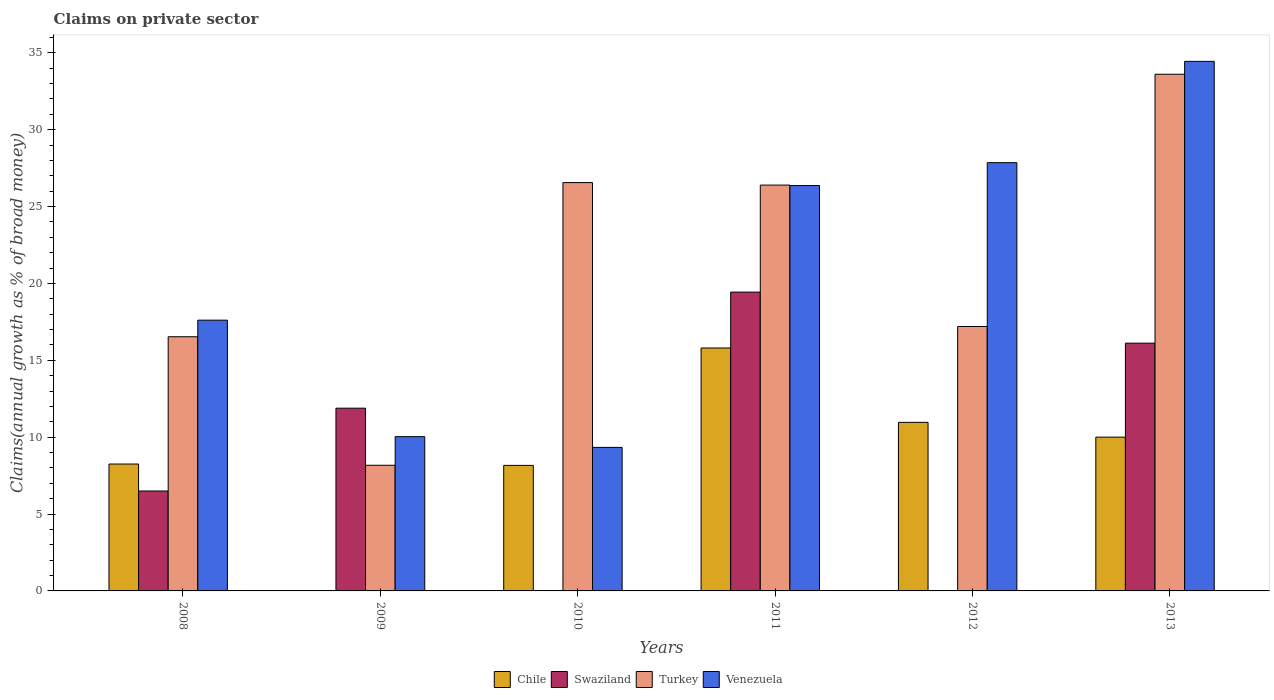How many groups of bars are there?
Provide a short and direct response. 6. Are the number of bars per tick equal to the number of legend labels?
Your response must be concise. No. Are the number of bars on each tick of the X-axis equal?
Provide a short and direct response. No. How many bars are there on the 1st tick from the left?
Your answer should be compact. 4. How many bars are there on the 6th tick from the right?
Give a very brief answer. 4. What is the label of the 1st group of bars from the left?
Provide a succinct answer. 2008. What is the percentage of broad money claimed on private sector in Venezuela in 2009?
Ensure brevity in your answer.  10.03. Across all years, what is the maximum percentage of broad money claimed on private sector in Venezuela?
Ensure brevity in your answer.  34.44. Across all years, what is the minimum percentage of broad money claimed on private sector in Turkey?
Your answer should be very brief. 8.17. In which year was the percentage of broad money claimed on private sector in Venezuela maximum?
Offer a very short reply. 2013. What is the total percentage of broad money claimed on private sector in Turkey in the graph?
Ensure brevity in your answer.  128.45. What is the difference between the percentage of broad money claimed on private sector in Swaziland in 2008 and that in 2011?
Your response must be concise. -12.94. What is the difference between the percentage of broad money claimed on private sector in Chile in 2011 and the percentage of broad money claimed on private sector in Turkey in 2010?
Ensure brevity in your answer.  -10.76. What is the average percentage of broad money claimed on private sector in Turkey per year?
Give a very brief answer. 21.41. In the year 2010, what is the difference between the percentage of broad money claimed on private sector in Venezuela and percentage of broad money claimed on private sector in Chile?
Provide a short and direct response. 1.17. What is the ratio of the percentage of broad money claimed on private sector in Swaziland in 2009 to that in 2013?
Your answer should be compact. 0.74. Is the difference between the percentage of broad money claimed on private sector in Venezuela in 2010 and 2012 greater than the difference between the percentage of broad money claimed on private sector in Chile in 2010 and 2012?
Your answer should be compact. No. What is the difference between the highest and the second highest percentage of broad money claimed on private sector in Chile?
Ensure brevity in your answer.  4.84. What is the difference between the highest and the lowest percentage of broad money claimed on private sector in Chile?
Your answer should be very brief. 15.8. Is the sum of the percentage of broad money claimed on private sector in Venezuela in 2009 and 2011 greater than the maximum percentage of broad money claimed on private sector in Turkey across all years?
Make the answer very short. Yes. Is it the case that in every year, the sum of the percentage of broad money claimed on private sector in Chile and percentage of broad money claimed on private sector in Turkey is greater than the sum of percentage of broad money claimed on private sector in Venezuela and percentage of broad money claimed on private sector in Swaziland?
Your answer should be very brief. No. Is it the case that in every year, the sum of the percentage of broad money claimed on private sector in Venezuela and percentage of broad money claimed on private sector in Chile is greater than the percentage of broad money claimed on private sector in Turkey?
Your answer should be very brief. No. How many years are there in the graph?
Give a very brief answer. 6. What is the difference between two consecutive major ticks on the Y-axis?
Offer a very short reply. 5. Are the values on the major ticks of Y-axis written in scientific E-notation?
Your answer should be compact. No. How many legend labels are there?
Give a very brief answer. 4. How are the legend labels stacked?
Give a very brief answer. Horizontal. What is the title of the graph?
Offer a very short reply. Claims on private sector. What is the label or title of the Y-axis?
Provide a short and direct response. Claims(annual growth as % of broad money). What is the Claims(annual growth as % of broad money) of Chile in 2008?
Give a very brief answer. 8.25. What is the Claims(annual growth as % of broad money) in Swaziland in 2008?
Your response must be concise. 6.5. What is the Claims(annual growth as % of broad money) of Turkey in 2008?
Keep it short and to the point. 16.53. What is the Claims(annual growth as % of broad money) of Venezuela in 2008?
Provide a succinct answer. 17.61. What is the Claims(annual growth as % of broad money) in Swaziland in 2009?
Offer a terse response. 11.89. What is the Claims(annual growth as % of broad money) of Turkey in 2009?
Offer a very short reply. 8.17. What is the Claims(annual growth as % of broad money) in Venezuela in 2009?
Ensure brevity in your answer.  10.03. What is the Claims(annual growth as % of broad money) in Chile in 2010?
Provide a succinct answer. 8.16. What is the Claims(annual growth as % of broad money) of Turkey in 2010?
Keep it short and to the point. 26.56. What is the Claims(annual growth as % of broad money) of Venezuela in 2010?
Provide a short and direct response. 9.33. What is the Claims(annual growth as % of broad money) in Chile in 2011?
Keep it short and to the point. 15.8. What is the Claims(annual growth as % of broad money) in Swaziland in 2011?
Your answer should be very brief. 19.43. What is the Claims(annual growth as % of broad money) of Turkey in 2011?
Give a very brief answer. 26.39. What is the Claims(annual growth as % of broad money) in Venezuela in 2011?
Offer a very short reply. 26.37. What is the Claims(annual growth as % of broad money) of Chile in 2012?
Offer a terse response. 10.96. What is the Claims(annual growth as % of broad money) of Turkey in 2012?
Ensure brevity in your answer.  17.2. What is the Claims(annual growth as % of broad money) of Venezuela in 2012?
Ensure brevity in your answer.  27.85. What is the Claims(annual growth as % of broad money) in Chile in 2013?
Your response must be concise. 10. What is the Claims(annual growth as % of broad money) in Swaziland in 2013?
Provide a succinct answer. 16.11. What is the Claims(annual growth as % of broad money) in Turkey in 2013?
Make the answer very short. 33.6. What is the Claims(annual growth as % of broad money) in Venezuela in 2013?
Your answer should be very brief. 34.44. Across all years, what is the maximum Claims(annual growth as % of broad money) in Chile?
Provide a short and direct response. 15.8. Across all years, what is the maximum Claims(annual growth as % of broad money) of Swaziland?
Your answer should be very brief. 19.43. Across all years, what is the maximum Claims(annual growth as % of broad money) of Turkey?
Your answer should be very brief. 33.6. Across all years, what is the maximum Claims(annual growth as % of broad money) of Venezuela?
Your answer should be compact. 34.44. Across all years, what is the minimum Claims(annual growth as % of broad money) in Chile?
Your answer should be very brief. 0. Across all years, what is the minimum Claims(annual growth as % of broad money) in Swaziland?
Your answer should be compact. 0. Across all years, what is the minimum Claims(annual growth as % of broad money) in Turkey?
Offer a very short reply. 8.17. Across all years, what is the minimum Claims(annual growth as % of broad money) of Venezuela?
Keep it short and to the point. 9.33. What is the total Claims(annual growth as % of broad money) of Chile in the graph?
Provide a succinct answer. 53.18. What is the total Claims(annual growth as % of broad money) of Swaziland in the graph?
Keep it short and to the point. 53.93. What is the total Claims(annual growth as % of broad money) of Turkey in the graph?
Keep it short and to the point. 128.45. What is the total Claims(annual growth as % of broad money) of Venezuela in the graph?
Make the answer very short. 125.64. What is the difference between the Claims(annual growth as % of broad money) of Swaziland in 2008 and that in 2009?
Make the answer very short. -5.39. What is the difference between the Claims(annual growth as % of broad money) in Turkey in 2008 and that in 2009?
Provide a short and direct response. 8.36. What is the difference between the Claims(annual growth as % of broad money) of Venezuela in 2008 and that in 2009?
Offer a very short reply. 7.58. What is the difference between the Claims(annual growth as % of broad money) of Chile in 2008 and that in 2010?
Offer a very short reply. 0.09. What is the difference between the Claims(annual growth as % of broad money) in Turkey in 2008 and that in 2010?
Your answer should be very brief. -10.03. What is the difference between the Claims(annual growth as % of broad money) in Venezuela in 2008 and that in 2010?
Give a very brief answer. 8.27. What is the difference between the Claims(annual growth as % of broad money) of Chile in 2008 and that in 2011?
Provide a short and direct response. -7.55. What is the difference between the Claims(annual growth as % of broad money) of Swaziland in 2008 and that in 2011?
Make the answer very short. -12.94. What is the difference between the Claims(annual growth as % of broad money) in Turkey in 2008 and that in 2011?
Offer a very short reply. -9.86. What is the difference between the Claims(annual growth as % of broad money) in Venezuela in 2008 and that in 2011?
Ensure brevity in your answer.  -8.76. What is the difference between the Claims(annual growth as % of broad money) in Chile in 2008 and that in 2012?
Your answer should be compact. -2.71. What is the difference between the Claims(annual growth as % of broad money) of Turkey in 2008 and that in 2012?
Give a very brief answer. -0.67. What is the difference between the Claims(annual growth as % of broad money) in Venezuela in 2008 and that in 2012?
Provide a short and direct response. -10.24. What is the difference between the Claims(annual growth as % of broad money) in Chile in 2008 and that in 2013?
Make the answer very short. -1.75. What is the difference between the Claims(annual growth as % of broad money) in Swaziland in 2008 and that in 2013?
Make the answer very short. -9.62. What is the difference between the Claims(annual growth as % of broad money) of Turkey in 2008 and that in 2013?
Offer a terse response. -17.07. What is the difference between the Claims(annual growth as % of broad money) of Venezuela in 2008 and that in 2013?
Ensure brevity in your answer.  -16.83. What is the difference between the Claims(annual growth as % of broad money) of Turkey in 2009 and that in 2010?
Your response must be concise. -18.39. What is the difference between the Claims(annual growth as % of broad money) of Venezuela in 2009 and that in 2010?
Give a very brief answer. 0.7. What is the difference between the Claims(annual growth as % of broad money) of Swaziland in 2009 and that in 2011?
Offer a terse response. -7.55. What is the difference between the Claims(annual growth as % of broad money) of Turkey in 2009 and that in 2011?
Provide a short and direct response. -18.22. What is the difference between the Claims(annual growth as % of broad money) of Venezuela in 2009 and that in 2011?
Make the answer very short. -16.33. What is the difference between the Claims(annual growth as % of broad money) of Turkey in 2009 and that in 2012?
Your response must be concise. -9.03. What is the difference between the Claims(annual growth as % of broad money) of Venezuela in 2009 and that in 2012?
Give a very brief answer. -17.82. What is the difference between the Claims(annual growth as % of broad money) of Swaziland in 2009 and that in 2013?
Your answer should be very brief. -4.23. What is the difference between the Claims(annual growth as % of broad money) of Turkey in 2009 and that in 2013?
Provide a short and direct response. -25.43. What is the difference between the Claims(annual growth as % of broad money) of Venezuela in 2009 and that in 2013?
Keep it short and to the point. -24.41. What is the difference between the Claims(annual growth as % of broad money) of Chile in 2010 and that in 2011?
Provide a short and direct response. -7.63. What is the difference between the Claims(annual growth as % of broad money) in Turkey in 2010 and that in 2011?
Offer a terse response. 0.16. What is the difference between the Claims(annual growth as % of broad money) of Venezuela in 2010 and that in 2011?
Your answer should be very brief. -17.03. What is the difference between the Claims(annual growth as % of broad money) of Chile in 2010 and that in 2012?
Provide a short and direct response. -2.8. What is the difference between the Claims(annual growth as % of broad money) of Turkey in 2010 and that in 2012?
Your answer should be compact. 9.36. What is the difference between the Claims(annual growth as % of broad money) in Venezuela in 2010 and that in 2012?
Your response must be concise. -18.52. What is the difference between the Claims(annual growth as % of broad money) of Chile in 2010 and that in 2013?
Offer a terse response. -1.84. What is the difference between the Claims(annual growth as % of broad money) of Turkey in 2010 and that in 2013?
Make the answer very short. -7.05. What is the difference between the Claims(annual growth as % of broad money) in Venezuela in 2010 and that in 2013?
Offer a very short reply. -25.11. What is the difference between the Claims(annual growth as % of broad money) in Chile in 2011 and that in 2012?
Make the answer very short. 4.84. What is the difference between the Claims(annual growth as % of broad money) in Turkey in 2011 and that in 2012?
Offer a terse response. 9.2. What is the difference between the Claims(annual growth as % of broad money) of Venezuela in 2011 and that in 2012?
Offer a terse response. -1.49. What is the difference between the Claims(annual growth as % of broad money) in Chile in 2011 and that in 2013?
Your response must be concise. 5.8. What is the difference between the Claims(annual growth as % of broad money) of Swaziland in 2011 and that in 2013?
Provide a short and direct response. 3.32. What is the difference between the Claims(annual growth as % of broad money) of Turkey in 2011 and that in 2013?
Make the answer very short. -7.21. What is the difference between the Claims(annual growth as % of broad money) in Venezuela in 2011 and that in 2013?
Your response must be concise. -8.08. What is the difference between the Claims(annual growth as % of broad money) in Chile in 2012 and that in 2013?
Provide a short and direct response. 0.96. What is the difference between the Claims(annual growth as % of broad money) of Turkey in 2012 and that in 2013?
Offer a very short reply. -16.41. What is the difference between the Claims(annual growth as % of broad money) of Venezuela in 2012 and that in 2013?
Your response must be concise. -6.59. What is the difference between the Claims(annual growth as % of broad money) of Chile in 2008 and the Claims(annual growth as % of broad money) of Swaziland in 2009?
Make the answer very short. -3.63. What is the difference between the Claims(annual growth as % of broad money) of Chile in 2008 and the Claims(annual growth as % of broad money) of Turkey in 2009?
Offer a very short reply. 0.08. What is the difference between the Claims(annual growth as % of broad money) of Chile in 2008 and the Claims(annual growth as % of broad money) of Venezuela in 2009?
Your answer should be very brief. -1.78. What is the difference between the Claims(annual growth as % of broad money) of Swaziland in 2008 and the Claims(annual growth as % of broad money) of Turkey in 2009?
Your answer should be very brief. -1.67. What is the difference between the Claims(annual growth as % of broad money) of Swaziland in 2008 and the Claims(annual growth as % of broad money) of Venezuela in 2009?
Your response must be concise. -3.54. What is the difference between the Claims(annual growth as % of broad money) of Turkey in 2008 and the Claims(annual growth as % of broad money) of Venezuela in 2009?
Your answer should be very brief. 6.5. What is the difference between the Claims(annual growth as % of broad money) of Chile in 2008 and the Claims(annual growth as % of broad money) of Turkey in 2010?
Ensure brevity in your answer.  -18.3. What is the difference between the Claims(annual growth as % of broad money) in Chile in 2008 and the Claims(annual growth as % of broad money) in Venezuela in 2010?
Make the answer very short. -1.08. What is the difference between the Claims(annual growth as % of broad money) of Swaziland in 2008 and the Claims(annual growth as % of broad money) of Turkey in 2010?
Make the answer very short. -20.06. What is the difference between the Claims(annual growth as % of broad money) in Swaziland in 2008 and the Claims(annual growth as % of broad money) in Venezuela in 2010?
Give a very brief answer. -2.84. What is the difference between the Claims(annual growth as % of broad money) of Turkey in 2008 and the Claims(annual growth as % of broad money) of Venezuela in 2010?
Your response must be concise. 7.2. What is the difference between the Claims(annual growth as % of broad money) in Chile in 2008 and the Claims(annual growth as % of broad money) in Swaziland in 2011?
Keep it short and to the point. -11.18. What is the difference between the Claims(annual growth as % of broad money) of Chile in 2008 and the Claims(annual growth as % of broad money) of Turkey in 2011?
Offer a very short reply. -18.14. What is the difference between the Claims(annual growth as % of broad money) of Chile in 2008 and the Claims(annual growth as % of broad money) of Venezuela in 2011?
Make the answer very short. -18.11. What is the difference between the Claims(annual growth as % of broad money) of Swaziland in 2008 and the Claims(annual growth as % of broad money) of Turkey in 2011?
Offer a very short reply. -19.9. What is the difference between the Claims(annual growth as % of broad money) in Swaziland in 2008 and the Claims(annual growth as % of broad money) in Venezuela in 2011?
Provide a succinct answer. -19.87. What is the difference between the Claims(annual growth as % of broad money) in Turkey in 2008 and the Claims(annual growth as % of broad money) in Venezuela in 2011?
Provide a short and direct response. -9.83. What is the difference between the Claims(annual growth as % of broad money) in Chile in 2008 and the Claims(annual growth as % of broad money) in Turkey in 2012?
Provide a short and direct response. -8.94. What is the difference between the Claims(annual growth as % of broad money) in Chile in 2008 and the Claims(annual growth as % of broad money) in Venezuela in 2012?
Your answer should be very brief. -19.6. What is the difference between the Claims(annual growth as % of broad money) of Swaziland in 2008 and the Claims(annual growth as % of broad money) of Turkey in 2012?
Offer a terse response. -10.7. What is the difference between the Claims(annual growth as % of broad money) in Swaziland in 2008 and the Claims(annual growth as % of broad money) in Venezuela in 2012?
Keep it short and to the point. -21.35. What is the difference between the Claims(annual growth as % of broad money) in Turkey in 2008 and the Claims(annual growth as % of broad money) in Venezuela in 2012?
Offer a terse response. -11.32. What is the difference between the Claims(annual growth as % of broad money) in Chile in 2008 and the Claims(annual growth as % of broad money) in Swaziland in 2013?
Your answer should be compact. -7.86. What is the difference between the Claims(annual growth as % of broad money) of Chile in 2008 and the Claims(annual growth as % of broad money) of Turkey in 2013?
Offer a terse response. -25.35. What is the difference between the Claims(annual growth as % of broad money) of Chile in 2008 and the Claims(annual growth as % of broad money) of Venezuela in 2013?
Ensure brevity in your answer.  -26.19. What is the difference between the Claims(annual growth as % of broad money) in Swaziland in 2008 and the Claims(annual growth as % of broad money) in Turkey in 2013?
Offer a terse response. -27.1. What is the difference between the Claims(annual growth as % of broad money) in Swaziland in 2008 and the Claims(annual growth as % of broad money) in Venezuela in 2013?
Offer a very short reply. -27.94. What is the difference between the Claims(annual growth as % of broad money) of Turkey in 2008 and the Claims(annual growth as % of broad money) of Venezuela in 2013?
Offer a very short reply. -17.91. What is the difference between the Claims(annual growth as % of broad money) of Swaziland in 2009 and the Claims(annual growth as % of broad money) of Turkey in 2010?
Keep it short and to the point. -14.67. What is the difference between the Claims(annual growth as % of broad money) in Swaziland in 2009 and the Claims(annual growth as % of broad money) in Venezuela in 2010?
Your answer should be very brief. 2.55. What is the difference between the Claims(annual growth as % of broad money) in Turkey in 2009 and the Claims(annual growth as % of broad money) in Venezuela in 2010?
Your answer should be very brief. -1.16. What is the difference between the Claims(annual growth as % of broad money) in Swaziland in 2009 and the Claims(annual growth as % of broad money) in Turkey in 2011?
Give a very brief answer. -14.51. What is the difference between the Claims(annual growth as % of broad money) of Swaziland in 2009 and the Claims(annual growth as % of broad money) of Venezuela in 2011?
Your answer should be very brief. -14.48. What is the difference between the Claims(annual growth as % of broad money) in Turkey in 2009 and the Claims(annual growth as % of broad money) in Venezuela in 2011?
Make the answer very short. -18.19. What is the difference between the Claims(annual growth as % of broad money) of Swaziland in 2009 and the Claims(annual growth as % of broad money) of Turkey in 2012?
Your answer should be very brief. -5.31. What is the difference between the Claims(annual growth as % of broad money) in Swaziland in 2009 and the Claims(annual growth as % of broad money) in Venezuela in 2012?
Ensure brevity in your answer.  -15.97. What is the difference between the Claims(annual growth as % of broad money) of Turkey in 2009 and the Claims(annual growth as % of broad money) of Venezuela in 2012?
Keep it short and to the point. -19.68. What is the difference between the Claims(annual growth as % of broad money) of Swaziland in 2009 and the Claims(annual growth as % of broad money) of Turkey in 2013?
Your response must be concise. -21.72. What is the difference between the Claims(annual growth as % of broad money) of Swaziland in 2009 and the Claims(annual growth as % of broad money) of Venezuela in 2013?
Keep it short and to the point. -22.56. What is the difference between the Claims(annual growth as % of broad money) in Turkey in 2009 and the Claims(annual growth as % of broad money) in Venezuela in 2013?
Give a very brief answer. -26.27. What is the difference between the Claims(annual growth as % of broad money) of Chile in 2010 and the Claims(annual growth as % of broad money) of Swaziland in 2011?
Make the answer very short. -11.27. What is the difference between the Claims(annual growth as % of broad money) in Chile in 2010 and the Claims(annual growth as % of broad money) in Turkey in 2011?
Provide a succinct answer. -18.23. What is the difference between the Claims(annual growth as % of broad money) of Chile in 2010 and the Claims(annual growth as % of broad money) of Venezuela in 2011?
Give a very brief answer. -18.2. What is the difference between the Claims(annual growth as % of broad money) in Turkey in 2010 and the Claims(annual growth as % of broad money) in Venezuela in 2011?
Your answer should be very brief. 0.19. What is the difference between the Claims(annual growth as % of broad money) in Chile in 2010 and the Claims(annual growth as % of broad money) in Turkey in 2012?
Your answer should be compact. -9.03. What is the difference between the Claims(annual growth as % of broad money) of Chile in 2010 and the Claims(annual growth as % of broad money) of Venezuela in 2012?
Keep it short and to the point. -19.69. What is the difference between the Claims(annual growth as % of broad money) of Turkey in 2010 and the Claims(annual growth as % of broad money) of Venezuela in 2012?
Provide a short and direct response. -1.3. What is the difference between the Claims(annual growth as % of broad money) in Chile in 2010 and the Claims(annual growth as % of broad money) in Swaziland in 2013?
Give a very brief answer. -7.95. What is the difference between the Claims(annual growth as % of broad money) of Chile in 2010 and the Claims(annual growth as % of broad money) of Turkey in 2013?
Ensure brevity in your answer.  -25.44. What is the difference between the Claims(annual growth as % of broad money) of Chile in 2010 and the Claims(annual growth as % of broad money) of Venezuela in 2013?
Offer a very short reply. -26.28. What is the difference between the Claims(annual growth as % of broad money) in Turkey in 2010 and the Claims(annual growth as % of broad money) in Venezuela in 2013?
Make the answer very short. -7.88. What is the difference between the Claims(annual growth as % of broad money) in Chile in 2011 and the Claims(annual growth as % of broad money) in Turkey in 2012?
Offer a very short reply. -1.4. What is the difference between the Claims(annual growth as % of broad money) in Chile in 2011 and the Claims(annual growth as % of broad money) in Venezuela in 2012?
Your answer should be very brief. -12.05. What is the difference between the Claims(annual growth as % of broad money) in Swaziland in 2011 and the Claims(annual growth as % of broad money) in Turkey in 2012?
Ensure brevity in your answer.  2.24. What is the difference between the Claims(annual growth as % of broad money) of Swaziland in 2011 and the Claims(annual growth as % of broad money) of Venezuela in 2012?
Keep it short and to the point. -8.42. What is the difference between the Claims(annual growth as % of broad money) in Turkey in 2011 and the Claims(annual growth as % of broad money) in Venezuela in 2012?
Give a very brief answer. -1.46. What is the difference between the Claims(annual growth as % of broad money) of Chile in 2011 and the Claims(annual growth as % of broad money) of Swaziland in 2013?
Offer a terse response. -0.32. What is the difference between the Claims(annual growth as % of broad money) in Chile in 2011 and the Claims(annual growth as % of broad money) in Turkey in 2013?
Your answer should be compact. -17.8. What is the difference between the Claims(annual growth as % of broad money) in Chile in 2011 and the Claims(annual growth as % of broad money) in Venezuela in 2013?
Make the answer very short. -18.64. What is the difference between the Claims(annual growth as % of broad money) in Swaziland in 2011 and the Claims(annual growth as % of broad money) in Turkey in 2013?
Provide a short and direct response. -14.17. What is the difference between the Claims(annual growth as % of broad money) in Swaziland in 2011 and the Claims(annual growth as % of broad money) in Venezuela in 2013?
Ensure brevity in your answer.  -15.01. What is the difference between the Claims(annual growth as % of broad money) in Turkey in 2011 and the Claims(annual growth as % of broad money) in Venezuela in 2013?
Give a very brief answer. -8.05. What is the difference between the Claims(annual growth as % of broad money) in Chile in 2012 and the Claims(annual growth as % of broad money) in Swaziland in 2013?
Give a very brief answer. -5.15. What is the difference between the Claims(annual growth as % of broad money) in Chile in 2012 and the Claims(annual growth as % of broad money) in Turkey in 2013?
Keep it short and to the point. -22.64. What is the difference between the Claims(annual growth as % of broad money) in Chile in 2012 and the Claims(annual growth as % of broad money) in Venezuela in 2013?
Provide a succinct answer. -23.48. What is the difference between the Claims(annual growth as % of broad money) in Turkey in 2012 and the Claims(annual growth as % of broad money) in Venezuela in 2013?
Offer a terse response. -17.24. What is the average Claims(annual growth as % of broad money) of Chile per year?
Your answer should be compact. 8.86. What is the average Claims(annual growth as % of broad money) in Swaziland per year?
Offer a very short reply. 8.99. What is the average Claims(annual growth as % of broad money) in Turkey per year?
Offer a very short reply. 21.41. What is the average Claims(annual growth as % of broad money) of Venezuela per year?
Offer a very short reply. 20.94. In the year 2008, what is the difference between the Claims(annual growth as % of broad money) in Chile and Claims(annual growth as % of broad money) in Swaziland?
Provide a succinct answer. 1.75. In the year 2008, what is the difference between the Claims(annual growth as % of broad money) in Chile and Claims(annual growth as % of broad money) in Turkey?
Give a very brief answer. -8.28. In the year 2008, what is the difference between the Claims(annual growth as % of broad money) of Chile and Claims(annual growth as % of broad money) of Venezuela?
Offer a very short reply. -9.36. In the year 2008, what is the difference between the Claims(annual growth as % of broad money) of Swaziland and Claims(annual growth as % of broad money) of Turkey?
Your answer should be compact. -10.03. In the year 2008, what is the difference between the Claims(annual growth as % of broad money) in Swaziland and Claims(annual growth as % of broad money) in Venezuela?
Your answer should be compact. -11.11. In the year 2008, what is the difference between the Claims(annual growth as % of broad money) of Turkey and Claims(annual growth as % of broad money) of Venezuela?
Your answer should be compact. -1.08. In the year 2009, what is the difference between the Claims(annual growth as % of broad money) in Swaziland and Claims(annual growth as % of broad money) in Turkey?
Make the answer very short. 3.71. In the year 2009, what is the difference between the Claims(annual growth as % of broad money) in Swaziland and Claims(annual growth as % of broad money) in Venezuela?
Offer a terse response. 1.85. In the year 2009, what is the difference between the Claims(annual growth as % of broad money) in Turkey and Claims(annual growth as % of broad money) in Venezuela?
Provide a succinct answer. -1.86. In the year 2010, what is the difference between the Claims(annual growth as % of broad money) in Chile and Claims(annual growth as % of broad money) in Turkey?
Provide a succinct answer. -18.39. In the year 2010, what is the difference between the Claims(annual growth as % of broad money) in Chile and Claims(annual growth as % of broad money) in Venezuela?
Keep it short and to the point. -1.17. In the year 2010, what is the difference between the Claims(annual growth as % of broad money) in Turkey and Claims(annual growth as % of broad money) in Venezuela?
Your answer should be compact. 17.22. In the year 2011, what is the difference between the Claims(annual growth as % of broad money) in Chile and Claims(annual growth as % of broad money) in Swaziland?
Your answer should be compact. -3.63. In the year 2011, what is the difference between the Claims(annual growth as % of broad money) of Chile and Claims(annual growth as % of broad money) of Turkey?
Offer a terse response. -10.59. In the year 2011, what is the difference between the Claims(annual growth as % of broad money) in Chile and Claims(annual growth as % of broad money) in Venezuela?
Ensure brevity in your answer.  -10.57. In the year 2011, what is the difference between the Claims(annual growth as % of broad money) of Swaziland and Claims(annual growth as % of broad money) of Turkey?
Offer a very short reply. -6.96. In the year 2011, what is the difference between the Claims(annual growth as % of broad money) in Swaziland and Claims(annual growth as % of broad money) in Venezuela?
Keep it short and to the point. -6.93. In the year 2011, what is the difference between the Claims(annual growth as % of broad money) in Turkey and Claims(annual growth as % of broad money) in Venezuela?
Make the answer very short. 0.03. In the year 2012, what is the difference between the Claims(annual growth as % of broad money) in Chile and Claims(annual growth as % of broad money) in Turkey?
Provide a succinct answer. -6.23. In the year 2012, what is the difference between the Claims(annual growth as % of broad money) in Chile and Claims(annual growth as % of broad money) in Venezuela?
Provide a succinct answer. -16.89. In the year 2012, what is the difference between the Claims(annual growth as % of broad money) in Turkey and Claims(annual growth as % of broad money) in Venezuela?
Provide a succinct answer. -10.66. In the year 2013, what is the difference between the Claims(annual growth as % of broad money) in Chile and Claims(annual growth as % of broad money) in Swaziland?
Your answer should be compact. -6.11. In the year 2013, what is the difference between the Claims(annual growth as % of broad money) in Chile and Claims(annual growth as % of broad money) in Turkey?
Provide a short and direct response. -23.6. In the year 2013, what is the difference between the Claims(annual growth as % of broad money) in Chile and Claims(annual growth as % of broad money) in Venezuela?
Provide a succinct answer. -24.44. In the year 2013, what is the difference between the Claims(annual growth as % of broad money) in Swaziland and Claims(annual growth as % of broad money) in Turkey?
Your answer should be very brief. -17.49. In the year 2013, what is the difference between the Claims(annual growth as % of broad money) in Swaziland and Claims(annual growth as % of broad money) in Venezuela?
Provide a short and direct response. -18.33. In the year 2013, what is the difference between the Claims(annual growth as % of broad money) in Turkey and Claims(annual growth as % of broad money) in Venezuela?
Offer a terse response. -0.84. What is the ratio of the Claims(annual growth as % of broad money) in Swaziland in 2008 to that in 2009?
Offer a terse response. 0.55. What is the ratio of the Claims(annual growth as % of broad money) in Turkey in 2008 to that in 2009?
Give a very brief answer. 2.02. What is the ratio of the Claims(annual growth as % of broad money) in Venezuela in 2008 to that in 2009?
Offer a terse response. 1.75. What is the ratio of the Claims(annual growth as % of broad money) of Chile in 2008 to that in 2010?
Your answer should be very brief. 1.01. What is the ratio of the Claims(annual growth as % of broad money) of Turkey in 2008 to that in 2010?
Your response must be concise. 0.62. What is the ratio of the Claims(annual growth as % of broad money) in Venezuela in 2008 to that in 2010?
Your answer should be very brief. 1.89. What is the ratio of the Claims(annual growth as % of broad money) in Chile in 2008 to that in 2011?
Ensure brevity in your answer.  0.52. What is the ratio of the Claims(annual growth as % of broad money) of Swaziland in 2008 to that in 2011?
Provide a succinct answer. 0.33. What is the ratio of the Claims(annual growth as % of broad money) in Turkey in 2008 to that in 2011?
Ensure brevity in your answer.  0.63. What is the ratio of the Claims(annual growth as % of broad money) in Venezuela in 2008 to that in 2011?
Make the answer very short. 0.67. What is the ratio of the Claims(annual growth as % of broad money) of Chile in 2008 to that in 2012?
Offer a very short reply. 0.75. What is the ratio of the Claims(annual growth as % of broad money) in Turkey in 2008 to that in 2012?
Ensure brevity in your answer.  0.96. What is the ratio of the Claims(annual growth as % of broad money) in Venezuela in 2008 to that in 2012?
Your response must be concise. 0.63. What is the ratio of the Claims(annual growth as % of broad money) of Chile in 2008 to that in 2013?
Your answer should be very brief. 0.83. What is the ratio of the Claims(annual growth as % of broad money) of Swaziland in 2008 to that in 2013?
Provide a short and direct response. 0.4. What is the ratio of the Claims(annual growth as % of broad money) in Turkey in 2008 to that in 2013?
Make the answer very short. 0.49. What is the ratio of the Claims(annual growth as % of broad money) in Venezuela in 2008 to that in 2013?
Give a very brief answer. 0.51. What is the ratio of the Claims(annual growth as % of broad money) of Turkey in 2009 to that in 2010?
Offer a very short reply. 0.31. What is the ratio of the Claims(annual growth as % of broad money) of Venezuela in 2009 to that in 2010?
Offer a terse response. 1.07. What is the ratio of the Claims(annual growth as % of broad money) in Swaziland in 2009 to that in 2011?
Your answer should be compact. 0.61. What is the ratio of the Claims(annual growth as % of broad money) of Turkey in 2009 to that in 2011?
Your answer should be compact. 0.31. What is the ratio of the Claims(annual growth as % of broad money) in Venezuela in 2009 to that in 2011?
Offer a very short reply. 0.38. What is the ratio of the Claims(annual growth as % of broad money) of Turkey in 2009 to that in 2012?
Your answer should be compact. 0.48. What is the ratio of the Claims(annual growth as % of broad money) of Venezuela in 2009 to that in 2012?
Provide a short and direct response. 0.36. What is the ratio of the Claims(annual growth as % of broad money) of Swaziland in 2009 to that in 2013?
Offer a very short reply. 0.74. What is the ratio of the Claims(annual growth as % of broad money) of Turkey in 2009 to that in 2013?
Offer a very short reply. 0.24. What is the ratio of the Claims(annual growth as % of broad money) in Venezuela in 2009 to that in 2013?
Give a very brief answer. 0.29. What is the ratio of the Claims(annual growth as % of broad money) in Chile in 2010 to that in 2011?
Your answer should be very brief. 0.52. What is the ratio of the Claims(annual growth as % of broad money) in Venezuela in 2010 to that in 2011?
Provide a short and direct response. 0.35. What is the ratio of the Claims(annual growth as % of broad money) in Chile in 2010 to that in 2012?
Your answer should be compact. 0.74. What is the ratio of the Claims(annual growth as % of broad money) of Turkey in 2010 to that in 2012?
Give a very brief answer. 1.54. What is the ratio of the Claims(annual growth as % of broad money) of Venezuela in 2010 to that in 2012?
Ensure brevity in your answer.  0.34. What is the ratio of the Claims(annual growth as % of broad money) of Chile in 2010 to that in 2013?
Ensure brevity in your answer.  0.82. What is the ratio of the Claims(annual growth as % of broad money) of Turkey in 2010 to that in 2013?
Ensure brevity in your answer.  0.79. What is the ratio of the Claims(annual growth as % of broad money) of Venezuela in 2010 to that in 2013?
Your answer should be compact. 0.27. What is the ratio of the Claims(annual growth as % of broad money) of Chile in 2011 to that in 2012?
Ensure brevity in your answer.  1.44. What is the ratio of the Claims(annual growth as % of broad money) in Turkey in 2011 to that in 2012?
Your answer should be very brief. 1.53. What is the ratio of the Claims(annual growth as % of broad money) in Venezuela in 2011 to that in 2012?
Offer a very short reply. 0.95. What is the ratio of the Claims(annual growth as % of broad money) in Chile in 2011 to that in 2013?
Provide a succinct answer. 1.58. What is the ratio of the Claims(annual growth as % of broad money) of Swaziland in 2011 to that in 2013?
Provide a short and direct response. 1.21. What is the ratio of the Claims(annual growth as % of broad money) in Turkey in 2011 to that in 2013?
Provide a succinct answer. 0.79. What is the ratio of the Claims(annual growth as % of broad money) in Venezuela in 2011 to that in 2013?
Provide a succinct answer. 0.77. What is the ratio of the Claims(annual growth as % of broad money) of Chile in 2012 to that in 2013?
Your answer should be compact. 1.1. What is the ratio of the Claims(annual growth as % of broad money) in Turkey in 2012 to that in 2013?
Make the answer very short. 0.51. What is the ratio of the Claims(annual growth as % of broad money) of Venezuela in 2012 to that in 2013?
Offer a terse response. 0.81. What is the difference between the highest and the second highest Claims(annual growth as % of broad money) in Chile?
Offer a terse response. 4.84. What is the difference between the highest and the second highest Claims(annual growth as % of broad money) of Swaziland?
Offer a terse response. 3.32. What is the difference between the highest and the second highest Claims(annual growth as % of broad money) of Turkey?
Ensure brevity in your answer.  7.05. What is the difference between the highest and the second highest Claims(annual growth as % of broad money) in Venezuela?
Make the answer very short. 6.59. What is the difference between the highest and the lowest Claims(annual growth as % of broad money) in Chile?
Offer a terse response. 15.8. What is the difference between the highest and the lowest Claims(annual growth as % of broad money) in Swaziland?
Offer a terse response. 19.43. What is the difference between the highest and the lowest Claims(annual growth as % of broad money) in Turkey?
Give a very brief answer. 25.43. What is the difference between the highest and the lowest Claims(annual growth as % of broad money) in Venezuela?
Give a very brief answer. 25.11. 